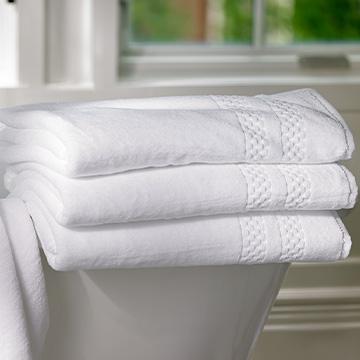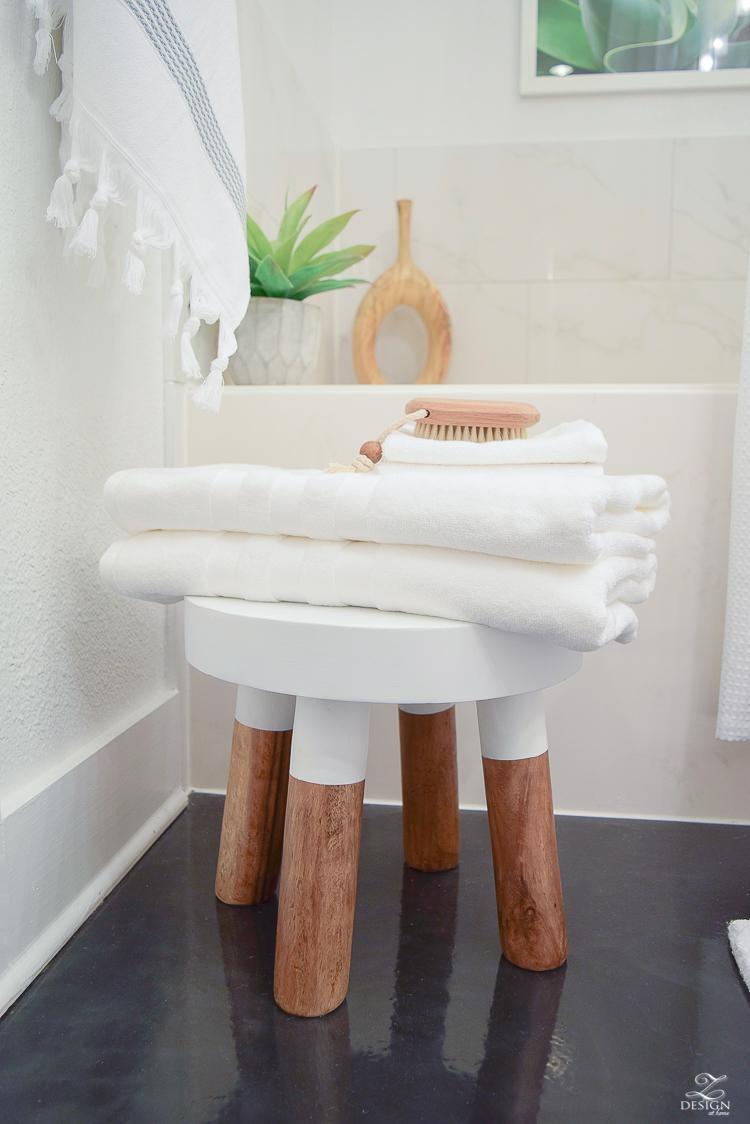The first image is the image on the left, the second image is the image on the right. For the images shown, is this caption "The left and right image contains the same number folded towels." true? Answer yes or no. No. The first image is the image on the left, the second image is the image on the right. Examine the images to the left and right. Is the description "In the left image there are three folded towels stacked together." accurate? Answer yes or no. Yes. 